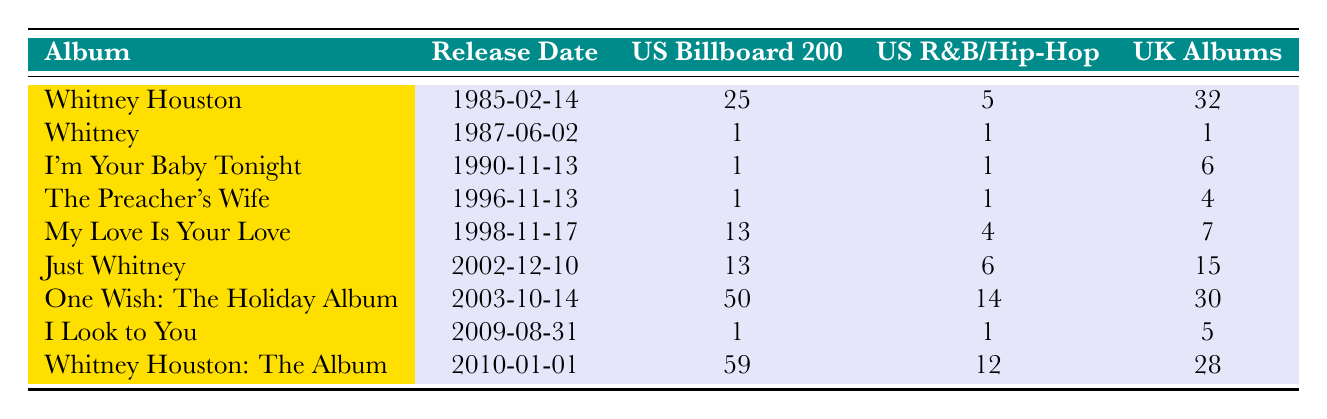What is the release date of Whitney Houston's first studio album? The first studio album listed in the table is "Whitney Houston," and its release date is provided in the second column. Looking at the table, it shows the release date as "1985-02-14."
Answer: 1985-02-14 Which album reached the highest chart position in the US Billboard 200? To find the highest chart position in the US Billboard 200, we need to look for the lowest number in that column. The albums "Whitney," "I'm Your Baby Tonight," "The Preacher's Wife," and "I Look to You" are all ranked number 1, which is the highest position.
Answer: Whitney, I'm Your Baby Tonight, The Preacher's Wife, I Look to You What is the average chart position for Whitney Houston's albums in the UK Albums Chart? To calculate the average position, we sum the UK chart positions: (32 + 1 + 6 + 4 + 7 + 15 + 30 + 5 + 28) = 128. There are 9 albums, so the average position is 128 / 9 = 14.22. The average chart position in the UK is approximately 14.22, which means it ranged around the 14th position.
Answer: Approximately 14.22 Did "My Love Is Your Love" achieve a number 1 position in the US Top R&B/Hip-Hop Albums? Looking at the chart position for "My Love Is Your Love," it shows "4" in the US Top R&B/Hip-Hop Albums column, indicating it did not reach number 1. Therefore, the answer is no.
Answer: No Which album had the lowest chart position in the US Billboard 200? The US Billboard 200 positions are compared based on the values in that column. The album "One Wish: The Holiday Album" has a chart position of "50," which is the lowest among all the albums.
Answer: One Wish: The Holiday Album How many albums reached number 1 on the UK Albums Chart? The table needs to be examined for albums that show "1" in the UK Albums Chart column. Those albums are "Whitney," "I'm Your Baby Tonight," "The Preacher's Wife," and "I Look to You," giving us a total of 4 albums with a number 1 position in the UK.
Answer: 4 What is the chart position difference between the highest and lowest ranked album on the US R&B/Hip-Hop chart? The highest chart position on the US R&B/Hip-Hop chart is "1" (for "Whitney," "I'm Your Baby Tonight," "The Preacher's Wife," and "I Look to You"), and the lowest is "14" for "One Wish: The Holiday Album." The difference is calculated as 14 - 1 = 13.
Answer: 13 Is "Just Whitney" ranked higher on the US Billboard 200 than "Whitney Houston"? Looking at the US Billboard 200 positions, "Just Whitney" is ranked "13," while "Whitney Houston" is ranked "25." Since 13 is a lower number than 25, "Just Whitney" is indeed ranked higher.
Answer: Yes What was the release date of Whitney Houston's last studio album listed in the table? The last studio album in the table is "Whitney Houston: The Album," which has its release date in the second column as "2010-01-01."
Answer: 2010-01-01 